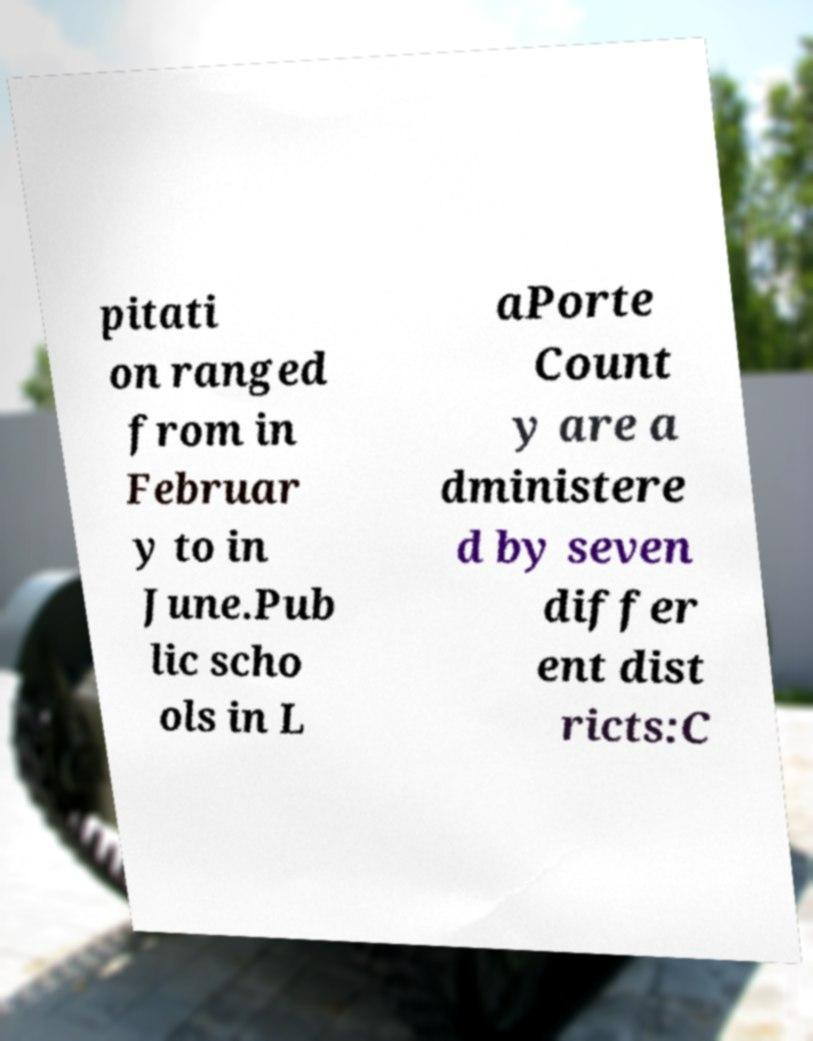For documentation purposes, I need the text within this image transcribed. Could you provide that? pitati on ranged from in Februar y to in June.Pub lic scho ols in L aPorte Count y are a dministere d by seven differ ent dist ricts:C 